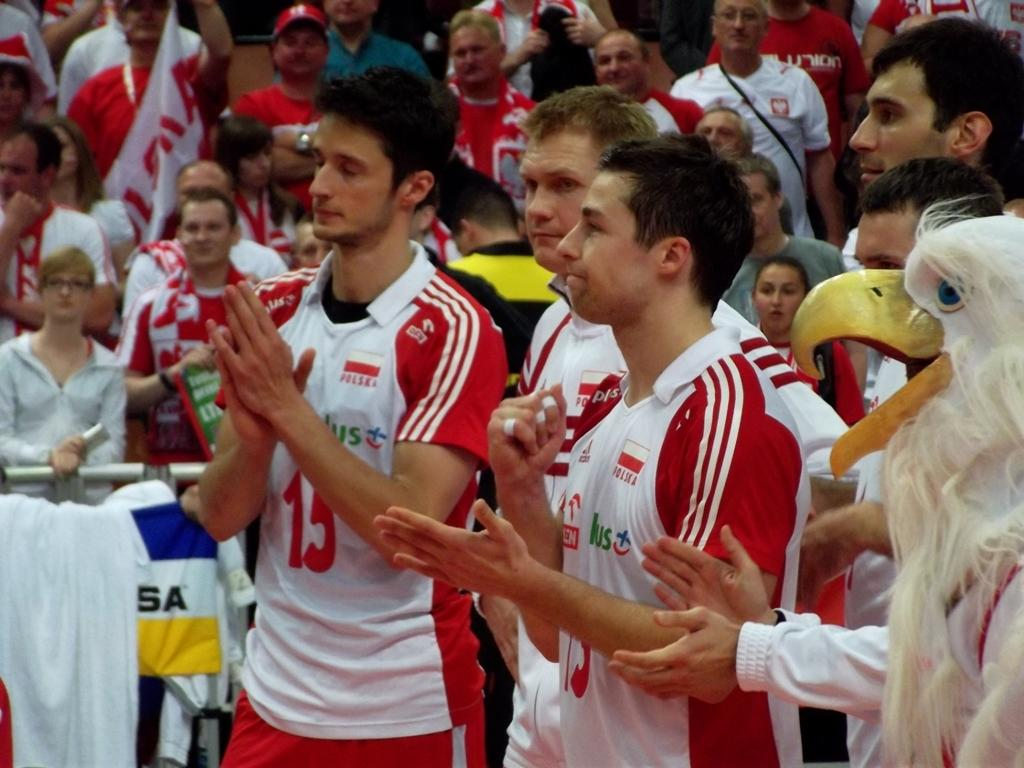<image>
Give a short and clear explanation of the subsequent image. the number 13 is on the jersey of the player 